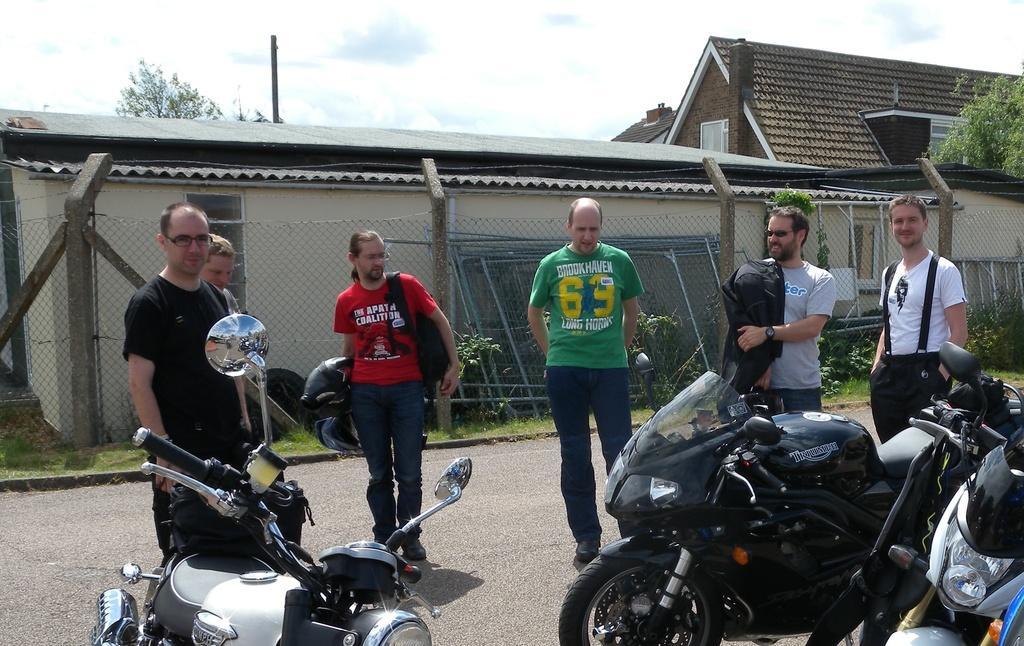Could you give a brief overview of what you see in this image? This image consists of five men standing on the road. At the bottom, there is a road. In the front, we can see three bikes parked on the road. In the background, there are small houses along with the fencing. At the top, there are clouds in the sky. On the right, there is a tree. Inside the fencing, there are small plants. 